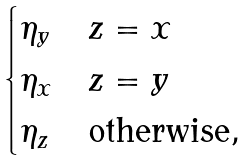Convert formula to latex. <formula><loc_0><loc_0><loc_500><loc_500>\begin{cases} \eta _ { y } & z = x \\ \eta _ { x } & z = y \\ \eta _ { z } & \text {otherwise} , \end{cases}</formula> 